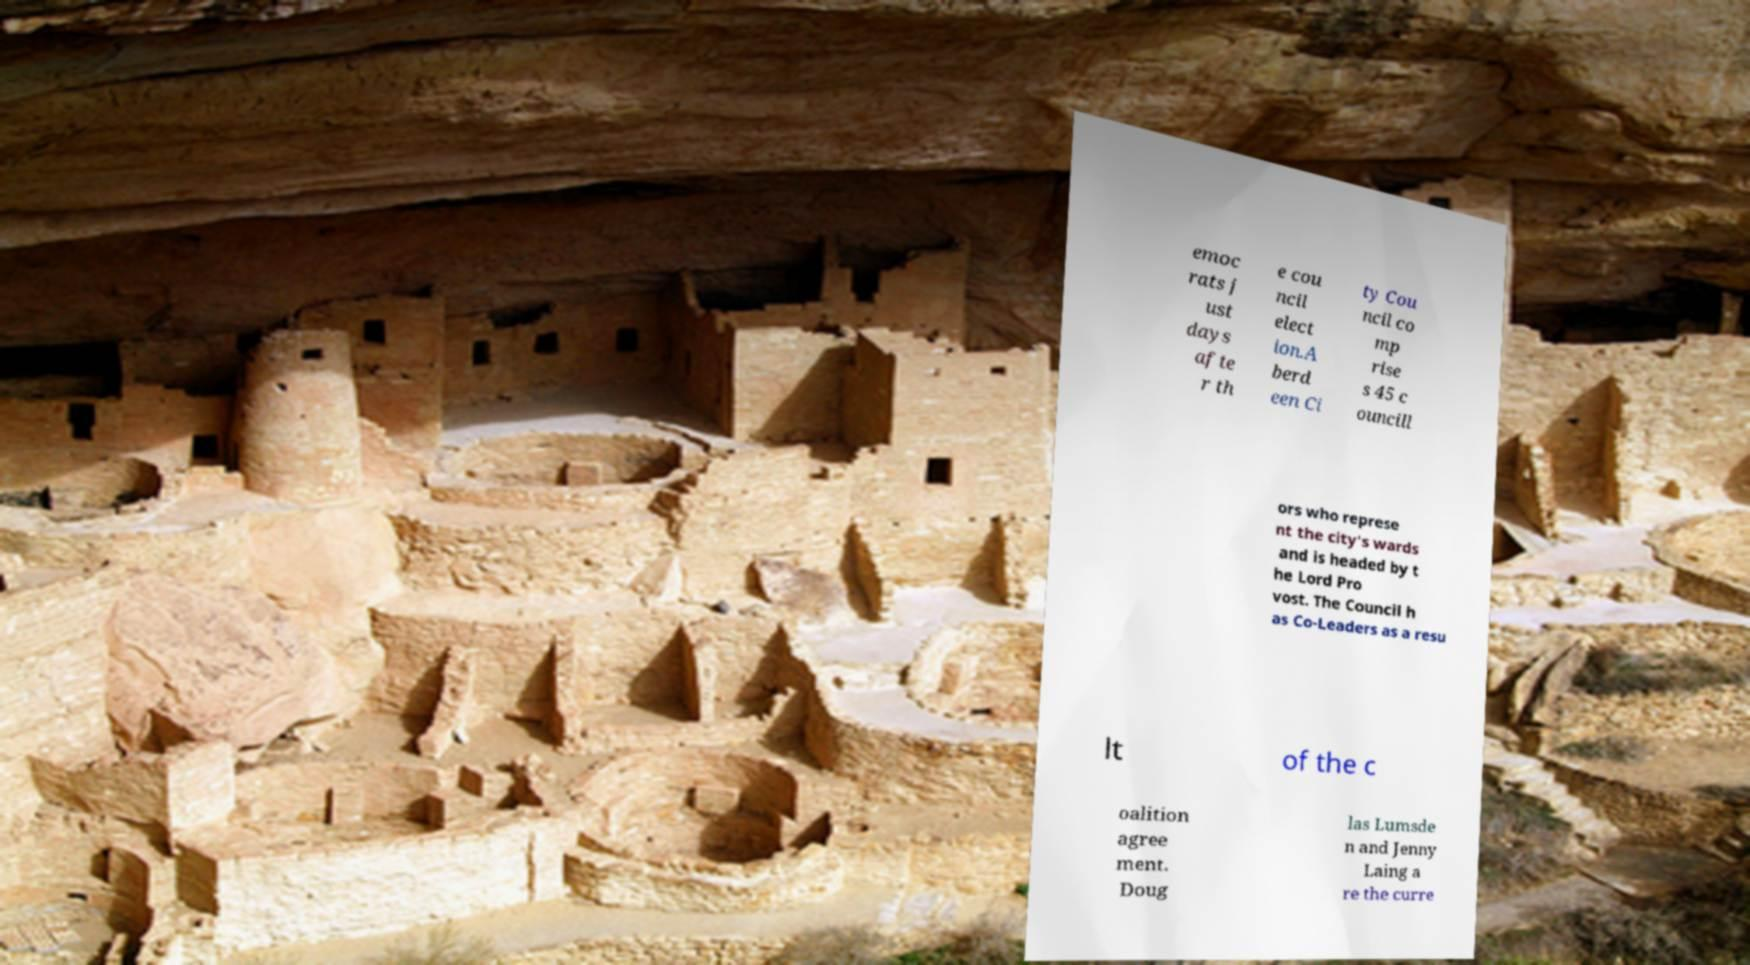Can you accurately transcribe the text from the provided image for me? emoc rats j ust days afte r th e cou ncil elect ion.A berd een Ci ty Cou ncil co mp rise s 45 c ouncill ors who represe nt the city's wards and is headed by t he Lord Pro vost. The Council h as Co-Leaders as a resu lt of the c oalition agree ment. Doug las Lumsde n and Jenny Laing a re the curre 